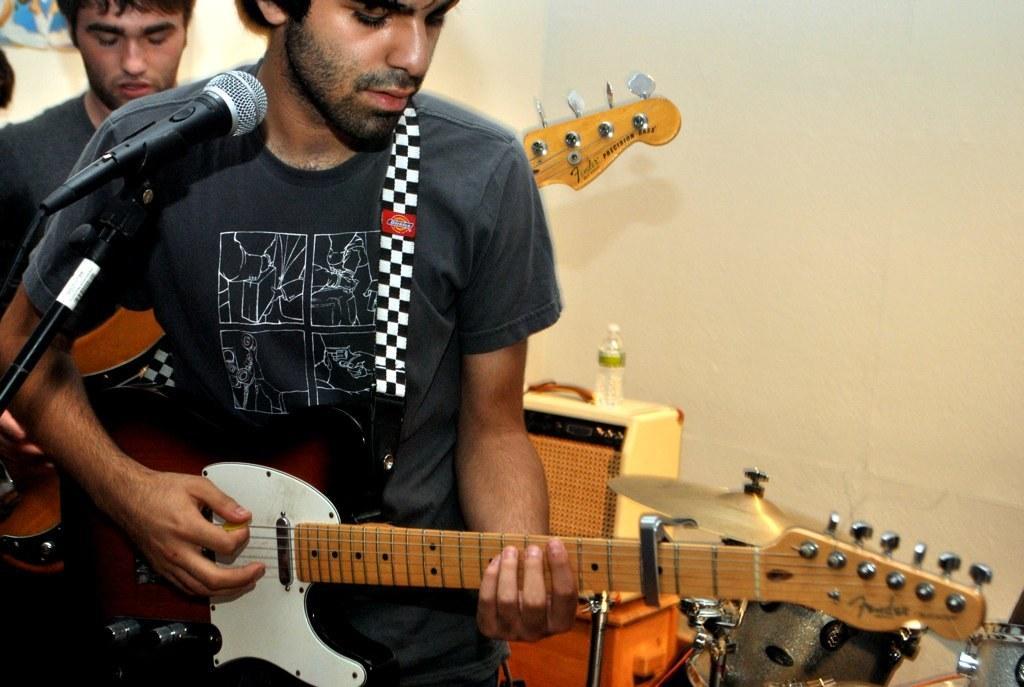Please provide a concise description of this image. There are two people. They both are standing and playing musical instruments. 